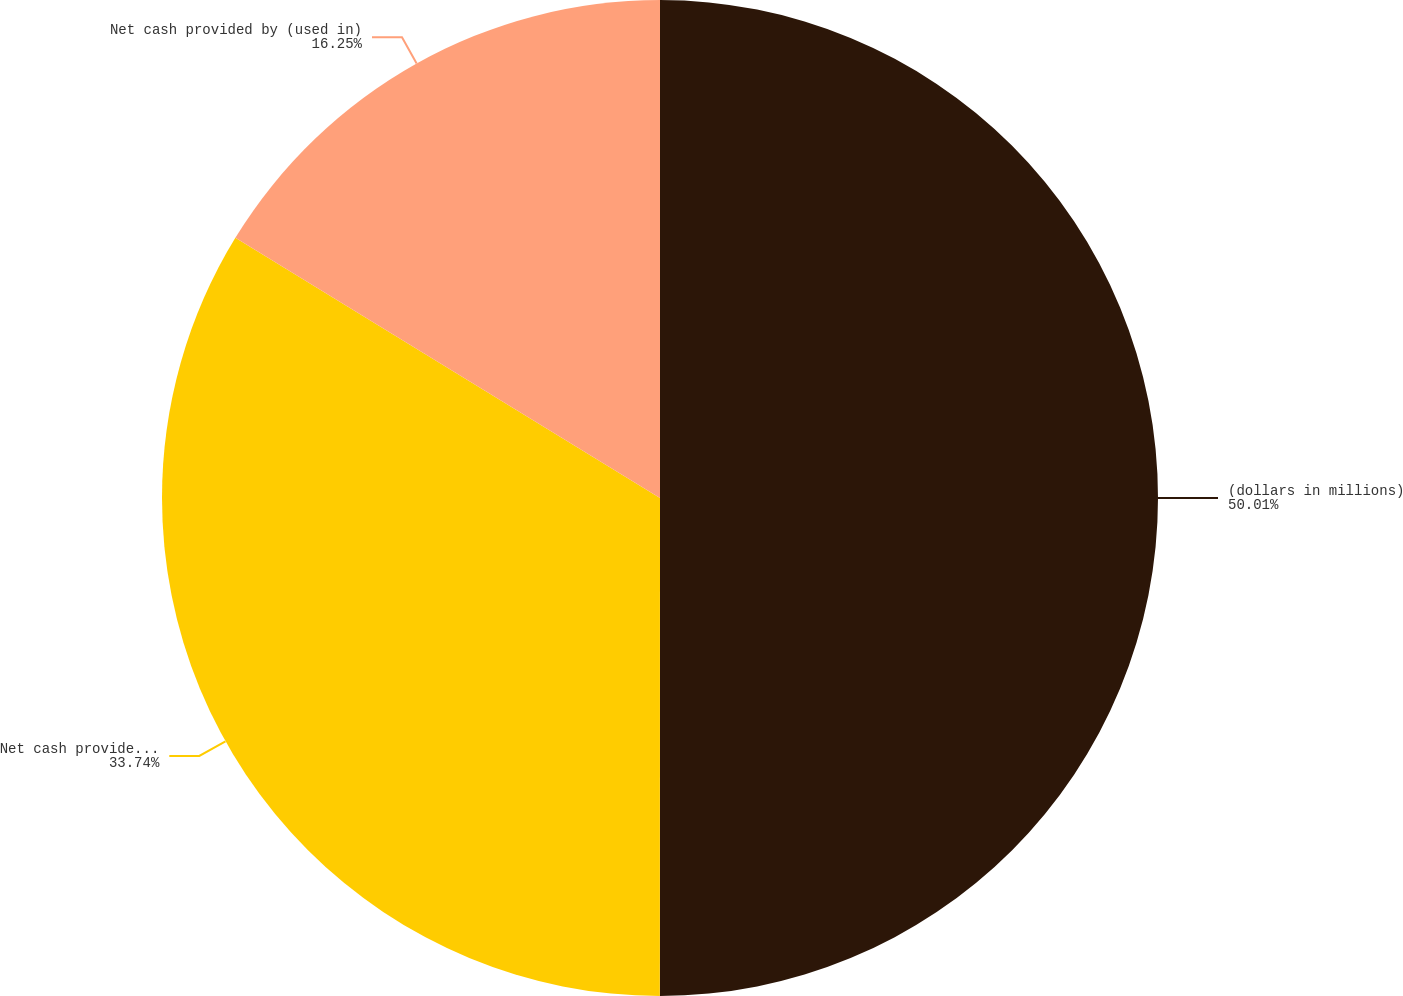Convert chart. <chart><loc_0><loc_0><loc_500><loc_500><pie_chart><fcel>(dollars in millions)<fcel>Net cash provided by operating<fcel>Net cash provided by (used in)<nl><fcel>50.0%<fcel>33.74%<fcel>16.25%<nl></chart> 